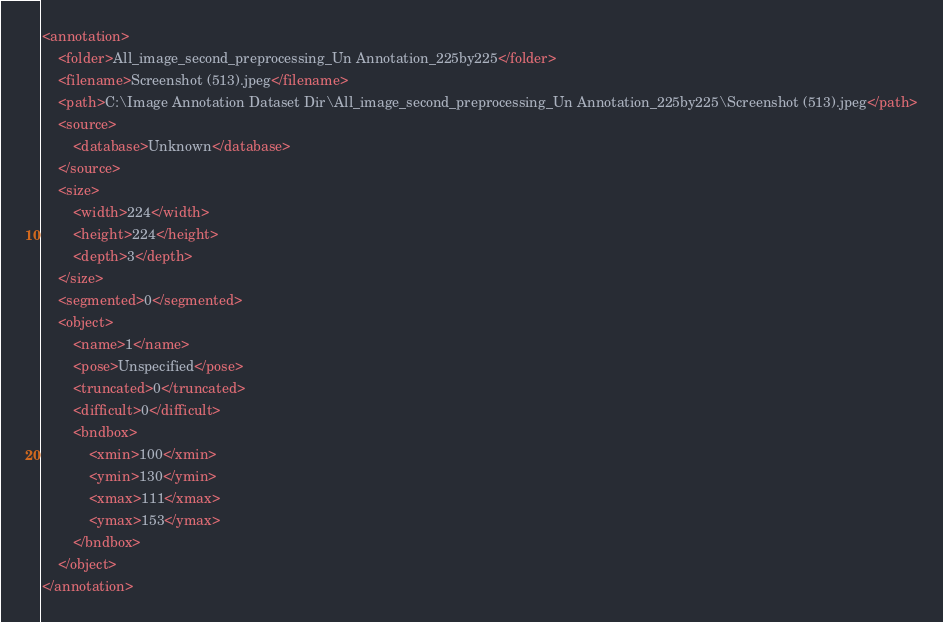<code> <loc_0><loc_0><loc_500><loc_500><_XML_><annotation>
	<folder>All_image_second_preprocessing_Un Annotation_225by225</folder>
	<filename>Screenshot (513).jpeg</filename>
	<path>C:\Image Annotation Dataset Dir\All_image_second_preprocessing_Un Annotation_225by225\Screenshot (513).jpeg</path>
	<source>
		<database>Unknown</database>
	</source>
	<size>
		<width>224</width>
		<height>224</height>
		<depth>3</depth>
	</size>
	<segmented>0</segmented>
	<object>
		<name>1</name>
		<pose>Unspecified</pose>
		<truncated>0</truncated>
		<difficult>0</difficult>
		<bndbox>
			<xmin>100</xmin>
			<ymin>130</ymin>
			<xmax>111</xmax>
			<ymax>153</ymax>
		</bndbox>
	</object>
</annotation>
</code> 